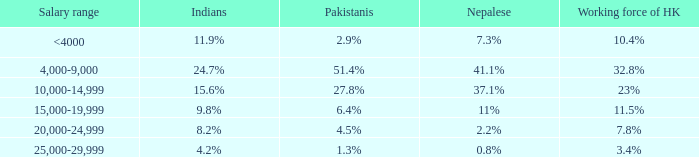Parse the full table. {'header': ['Salary range', 'Indians', 'Pakistanis', 'Nepalese', 'Working force of HK'], 'rows': [['<4000', '11.9%', '2.9%', '7.3%', '10.4%'], ['4,000-9,000', '24.7%', '51.4%', '41.1%', '32.8%'], ['10,000-14,999', '15.6%', '27.8%', '37.1%', '23%'], ['15,000-19,999', '9.8%', '6.4%', '11%', '11.5%'], ['20,000-24,999', '8.2%', '4.5%', '2.2%', '7.8%'], ['25,000-29,999', '4.2%', '1.3%', '0.8%', '3.4%']]} If the working force of HK is 10.4%, what is the salary range? <4000. 